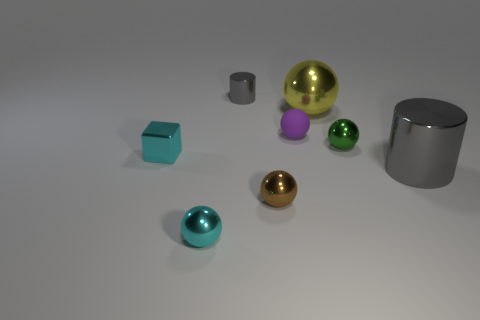How many other things are there of the same size as the cyan shiny sphere?
Provide a short and direct response. 5. Do the gray object that is left of the tiny matte ball and the object that is to the right of the small green metal ball have the same shape?
Your answer should be very brief. Yes. How many objects are either blue shiny cylinders or gray metallic cylinders that are right of the small green sphere?
Give a very brief answer. 1. The tiny object that is both to the right of the brown thing and behind the green metal sphere is made of what material?
Ensure brevity in your answer.  Rubber. What color is the tiny cylinder that is made of the same material as the tiny green thing?
Ensure brevity in your answer.  Gray. What number of things are brown metal things or large green shiny cylinders?
Your answer should be very brief. 1. Does the yellow metal thing have the same size as the brown ball that is on the left side of the small green metallic object?
Provide a succinct answer. No. There is a cylinder that is on the left side of the cylinder that is on the right side of the big object that is behind the cyan metallic block; what is its color?
Your answer should be very brief. Gray. The matte ball has what color?
Make the answer very short. Purple. Is the number of small green metal balls in front of the large yellow shiny thing greater than the number of big balls that are in front of the cyan ball?
Offer a terse response. Yes. 